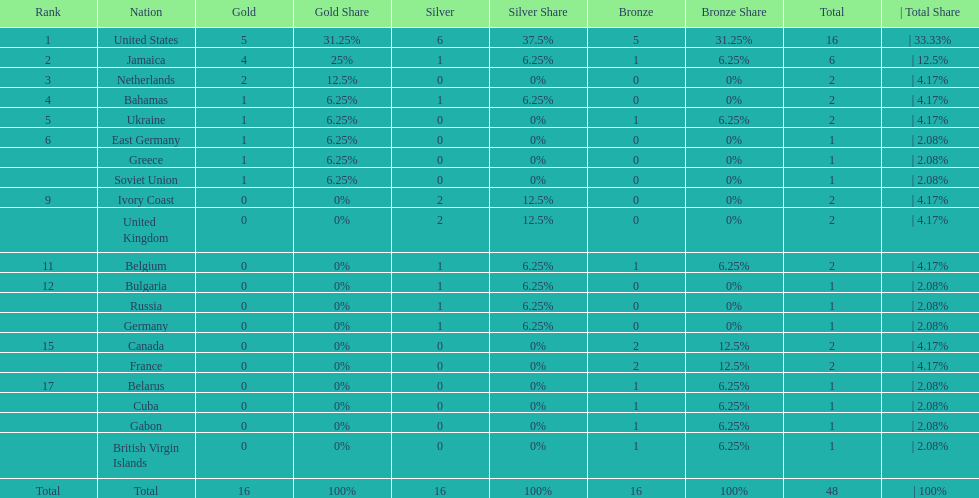What country won the most silver medals? United States. 